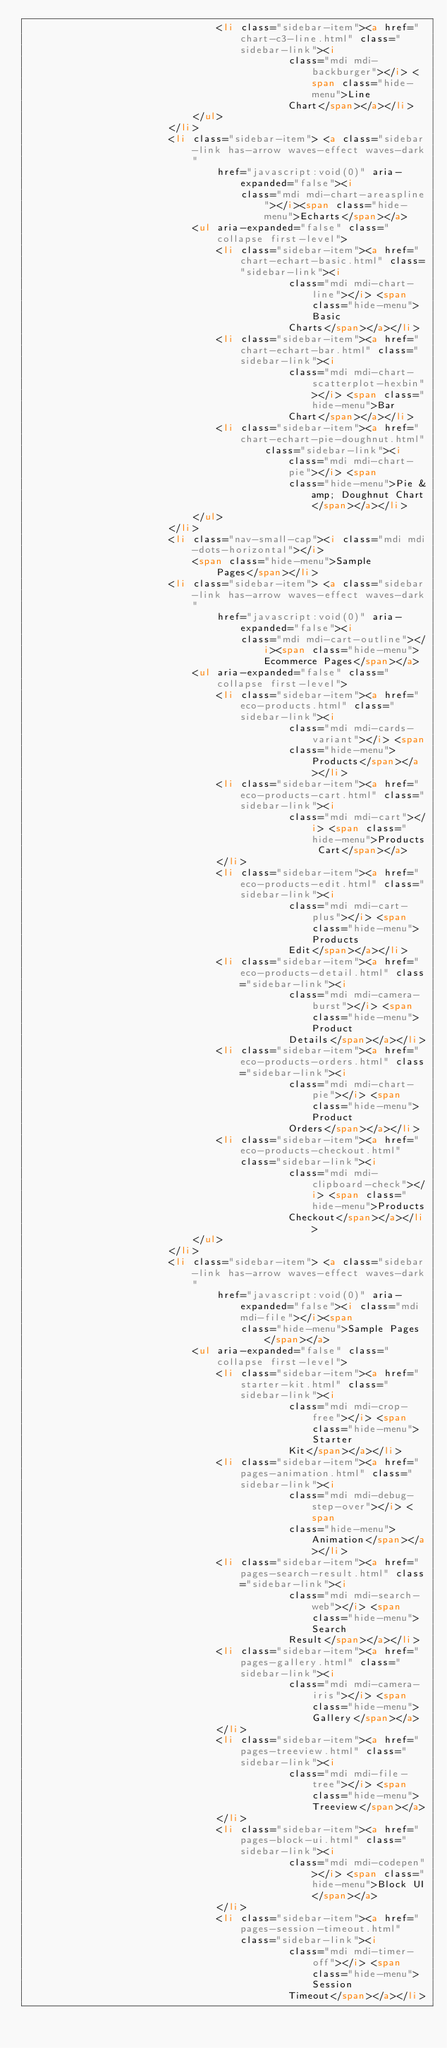Convert code to text. <code><loc_0><loc_0><loc_500><loc_500><_HTML_>                                <li class="sidebar-item"><a href="chart-c3-line.html" class="sidebar-link"><i
                                            class="mdi mdi-backburger"></i> <span class="hide-menu">Line
                                            Chart</span></a></li>
                            </ul>
                        </li>
                        <li class="sidebar-item"> <a class="sidebar-link has-arrow waves-effect waves-dark"
                                href="javascript:void(0)" aria-expanded="false"><i
                                    class="mdi mdi-chart-areaspline"></i><span class="hide-menu">Echarts</span></a>
                            <ul aria-expanded="false" class="collapse first-level">
                                <li class="sidebar-item"><a href="chart-echart-basic.html" class="sidebar-link"><i
                                            class="mdi mdi-chart-line"></i> <span class="hide-menu">Basic
                                            Charts</span></a></li>
                                <li class="sidebar-item"><a href="chart-echart-bar.html" class="sidebar-link"><i
                                            class="mdi mdi-chart-scatterplot-hexbin"></i> <span class="hide-menu">Bar
                                            Chart</span></a></li>
                                <li class="sidebar-item"><a href="chart-echart-pie-doughnut.html"
                                        class="sidebar-link"><i class="mdi mdi-chart-pie"></i> <span
                                            class="hide-menu">Pie &amp; Doughnut Chart</span></a></li>
                            </ul>
                        </li>
                        <li class="nav-small-cap"><i class="mdi mdi-dots-horizontal"></i>
                            <span class="hide-menu">Sample
                                Pages</span></li>
                        <li class="sidebar-item"> <a class="sidebar-link has-arrow waves-effect waves-dark"
                                href="javascript:void(0)" aria-expanded="false"><i
                                    class="mdi mdi-cart-outline"></i><span class="hide-menu">Ecommerce Pages</span></a>
                            <ul aria-expanded="false" class="collapse first-level">
                                <li class="sidebar-item"><a href="eco-products.html" class="sidebar-link"><i
                                            class="mdi mdi-cards-variant"></i> <span
                                            class="hide-menu">Products</span></a></li>
                                <li class="sidebar-item"><a href="eco-products-cart.html" class="sidebar-link"><i
                                            class="mdi mdi-cart"></i> <span class="hide-menu">Products Cart</span></a>
                                </li>
                                <li class="sidebar-item"><a href="eco-products-edit.html" class="sidebar-link"><i
                                            class="mdi mdi-cart-plus"></i> <span class="hide-menu">Products
                                            Edit</span></a></li>
                                <li class="sidebar-item"><a href="eco-products-detail.html" class="sidebar-link"><i
                                            class="mdi mdi-camera-burst"></i> <span class="hide-menu">Product
                                            Details</span></a></li>
                                <li class="sidebar-item"><a href="eco-products-orders.html" class="sidebar-link"><i
                                            class="mdi mdi-chart-pie"></i> <span class="hide-menu">Product
                                            Orders</span></a></li>
                                <li class="sidebar-item"><a href="eco-products-checkout.html" class="sidebar-link"><i
                                            class="mdi mdi-clipboard-check"></i> <span class="hide-menu">Products
                                            Checkout</span></a></li>
                            </ul>
                        </li>
                        <li class="sidebar-item"> <a class="sidebar-link has-arrow waves-effect waves-dark"
                                href="javascript:void(0)" aria-expanded="false"><i class="mdi mdi-file"></i><span
                                    class="hide-menu">Sample Pages </span></a>
                            <ul aria-expanded="false" class="collapse first-level">
                                <li class="sidebar-item"><a href="starter-kit.html" class="sidebar-link"><i
                                            class="mdi mdi-crop-free"></i> <span class="hide-menu">Starter
                                            Kit</span></a></li>
                                <li class="sidebar-item"><a href="pages-animation.html" class="sidebar-link"><i
                                            class="mdi mdi-debug-step-over"></i> <span
                                            class="hide-menu">Animation</span></a></li>
                                <li class="sidebar-item"><a href="pages-search-result.html" class="sidebar-link"><i
                                            class="mdi mdi-search-web"></i> <span class="hide-menu">Search
                                            Result</span></a></li>
                                <li class="sidebar-item"><a href="pages-gallery.html" class="sidebar-link"><i
                                            class="mdi mdi-camera-iris"></i> <span class="hide-menu">Gallery</span></a>
                                </li>
                                <li class="sidebar-item"><a href="pages-treeview.html" class="sidebar-link"><i
                                            class="mdi mdi-file-tree"></i> <span class="hide-menu">Treeview</span></a>
                                </li>
                                <li class="sidebar-item"><a href="pages-block-ui.html" class="sidebar-link"><i
                                            class="mdi mdi-codepen"></i> <span class="hide-menu">Block UI</span></a>
                                </li>
                                <li class="sidebar-item"><a href="pages-session-timeout.html" class="sidebar-link"><i
                                            class="mdi mdi-timer-off"></i> <span class="hide-menu">Session
                                            Timeout</span></a></li></code> 